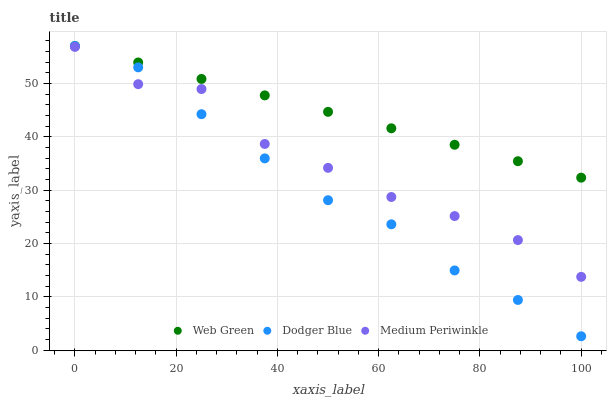Does Dodger Blue have the minimum area under the curve?
Answer yes or no. Yes. Does Web Green have the maximum area under the curve?
Answer yes or no. Yes. Does Web Green have the minimum area under the curve?
Answer yes or no. No. Does Dodger Blue have the maximum area under the curve?
Answer yes or no. No. Is Web Green the smoothest?
Answer yes or no. Yes. Is Medium Periwinkle the roughest?
Answer yes or no. Yes. Is Dodger Blue the smoothest?
Answer yes or no. No. Is Dodger Blue the roughest?
Answer yes or no. No. Does Dodger Blue have the lowest value?
Answer yes or no. Yes. Does Web Green have the lowest value?
Answer yes or no. No. Does Web Green have the highest value?
Answer yes or no. Yes. Is Medium Periwinkle less than Web Green?
Answer yes or no. Yes. Is Web Green greater than Medium Periwinkle?
Answer yes or no. Yes. Does Dodger Blue intersect Web Green?
Answer yes or no. Yes. Is Dodger Blue less than Web Green?
Answer yes or no. No. Is Dodger Blue greater than Web Green?
Answer yes or no. No. Does Medium Periwinkle intersect Web Green?
Answer yes or no. No. 